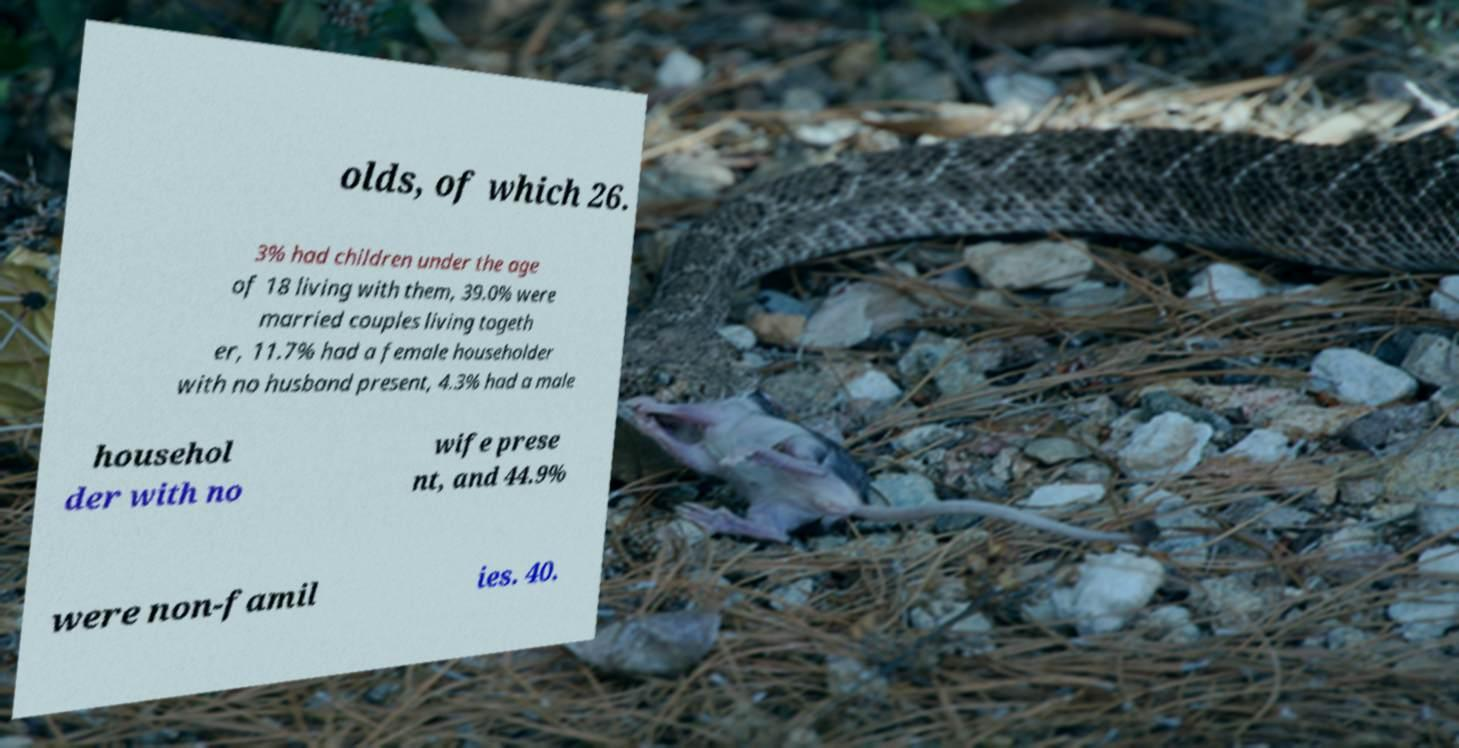Could you extract and type out the text from this image? olds, of which 26. 3% had children under the age of 18 living with them, 39.0% were married couples living togeth er, 11.7% had a female householder with no husband present, 4.3% had a male househol der with no wife prese nt, and 44.9% were non-famil ies. 40. 